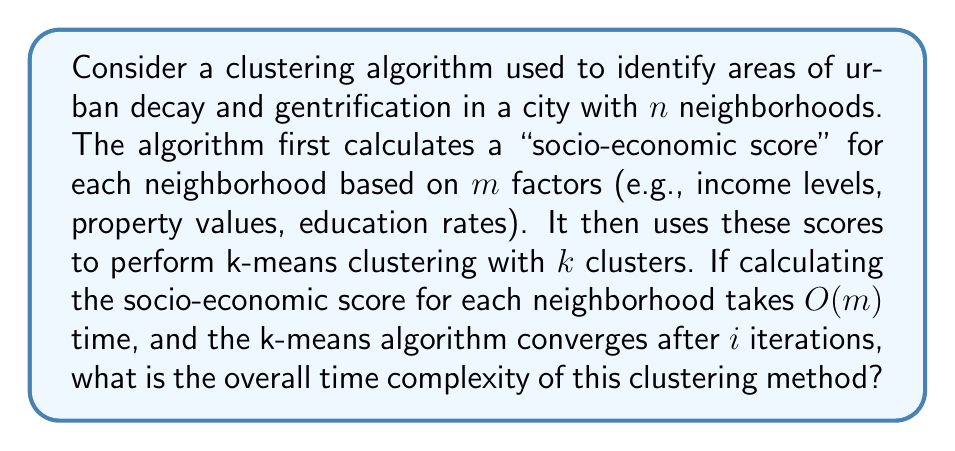What is the answer to this math problem? To determine the overall time complexity, let's break down the algorithm into its main components:

1. Calculating socio-economic scores:
   - For each of the $n$ neighborhoods, we calculate a score based on $m$ factors.
   - Time complexity for one neighborhood: $O(m)$
   - Total time complexity for all neighborhoods: $O(nm)$

2. K-means clustering:
   - Initialization: Randomly select $k$ centroids - $O(k)$
   - For each iteration (total of $i$ iterations):
     a. Assign each point to the nearest centroid:
        - Compare each of $n$ points to $k$ centroids: $O(nk)$
     b. Recalculate centroids:
        - Update $k$ centroids based on assigned points: $O(n)$
   - Total time complexity for k-means: $O(k + i(nk + n)) = O(ink)$

Combining these components:
Total time complexity = $O(nm) + O(ink)$

Since $k$ is typically much smaller than $n$, and $i$ is often considered a constant (as k-means usually converges quickly), we can simplify this to:
$O(nm + nk) = O(n(m + k))$

This represents the overall time complexity of the clustering method.
Answer: The overall time complexity of the clustering method is $O(n(m + k))$, where $n$ is the number of neighborhoods, $m$ is the number of factors used to calculate the socio-economic score, and $k$ is the number of clusters. 